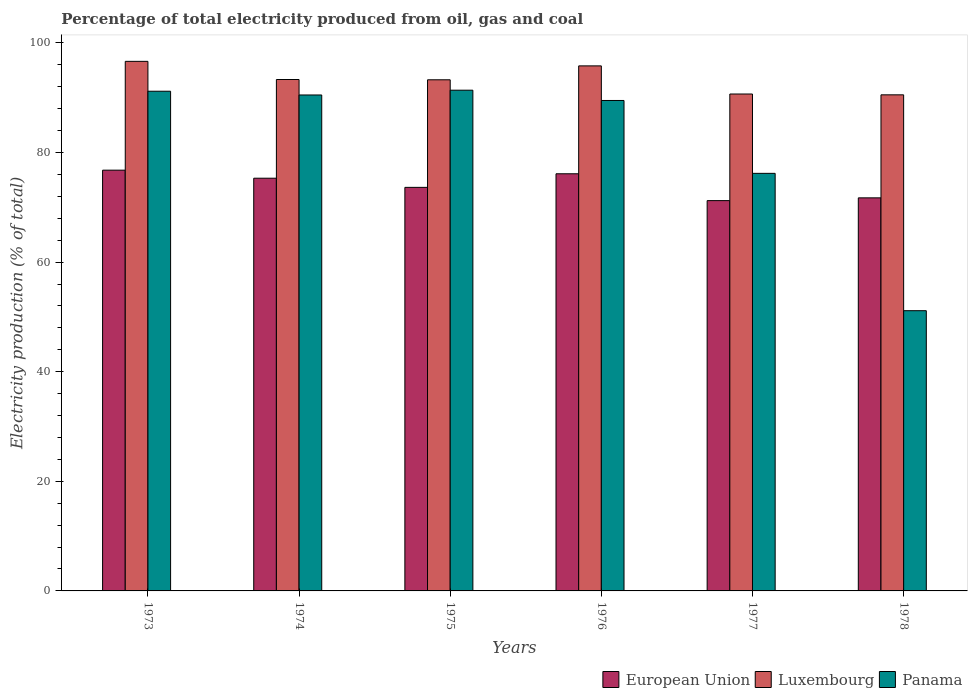How many different coloured bars are there?
Provide a succinct answer. 3. Are the number of bars per tick equal to the number of legend labels?
Offer a very short reply. Yes. Are the number of bars on each tick of the X-axis equal?
Your response must be concise. Yes. How many bars are there on the 3rd tick from the right?
Keep it short and to the point. 3. What is the label of the 3rd group of bars from the left?
Offer a very short reply. 1975. What is the electricity production in in Luxembourg in 1974?
Offer a very short reply. 93.32. Across all years, what is the maximum electricity production in in Panama?
Offer a terse response. 91.37. Across all years, what is the minimum electricity production in in European Union?
Offer a very short reply. 71.22. In which year was the electricity production in in Luxembourg minimum?
Keep it short and to the point. 1978. What is the total electricity production in in European Union in the graph?
Provide a short and direct response. 444.77. What is the difference between the electricity production in in Panama in 1973 and that in 1974?
Provide a succinct answer. 0.69. What is the difference between the electricity production in in Luxembourg in 1977 and the electricity production in in Panama in 1976?
Offer a very short reply. 1.18. What is the average electricity production in in European Union per year?
Provide a short and direct response. 74.13. In the year 1975, what is the difference between the electricity production in in European Union and electricity production in in Luxembourg?
Give a very brief answer. -19.63. In how many years, is the electricity production in in Luxembourg greater than 44 %?
Give a very brief answer. 6. What is the ratio of the electricity production in in Panama in 1974 to that in 1977?
Offer a very short reply. 1.19. Is the electricity production in in Luxembourg in 1973 less than that in 1974?
Your response must be concise. No. What is the difference between the highest and the second highest electricity production in in Luxembourg?
Make the answer very short. 0.83. What is the difference between the highest and the lowest electricity production in in Panama?
Your answer should be very brief. 40.24. In how many years, is the electricity production in in Panama greater than the average electricity production in in Panama taken over all years?
Your answer should be very brief. 4. What does the 1st bar from the left in 1973 represents?
Your answer should be very brief. European Union. What does the 1st bar from the right in 1973 represents?
Give a very brief answer. Panama. Is it the case that in every year, the sum of the electricity production in in Luxembourg and electricity production in in Panama is greater than the electricity production in in European Union?
Offer a very short reply. Yes. How many bars are there?
Offer a very short reply. 18. Are all the bars in the graph horizontal?
Make the answer very short. No. Where does the legend appear in the graph?
Provide a succinct answer. Bottom right. How many legend labels are there?
Provide a short and direct response. 3. What is the title of the graph?
Offer a terse response. Percentage of total electricity produced from oil, gas and coal. What is the label or title of the Y-axis?
Keep it short and to the point. Electricity production (% of total). What is the Electricity production (% of total) of European Union in 1973?
Make the answer very short. 76.77. What is the Electricity production (% of total) of Luxembourg in 1973?
Your answer should be very brief. 96.63. What is the Electricity production (% of total) of Panama in 1973?
Your answer should be compact. 91.18. What is the Electricity production (% of total) of European Union in 1974?
Provide a succinct answer. 75.3. What is the Electricity production (% of total) in Luxembourg in 1974?
Offer a very short reply. 93.32. What is the Electricity production (% of total) in Panama in 1974?
Your response must be concise. 90.49. What is the Electricity production (% of total) of European Union in 1975?
Your response must be concise. 73.63. What is the Electricity production (% of total) in Luxembourg in 1975?
Your answer should be very brief. 93.26. What is the Electricity production (% of total) in Panama in 1975?
Make the answer very short. 91.37. What is the Electricity production (% of total) in European Union in 1976?
Keep it short and to the point. 76.11. What is the Electricity production (% of total) of Luxembourg in 1976?
Provide a short and direct response. 95.8. What is the Electricity production (% of total) of Panama in 1976?
Provide a short and direct response. 89.49. What is the Electricity production (% of total) in European Union in 1977?
Keep it short and to the point. 71.22. What is the Electricity production (% of total) of Luxembourg in 1977?
Make the answer very short. 90.67. What is the Electricity production (% of total) of Panama in 1977?
Offer a terse response. 76.19. What is the Electricity production (% of total) in European Union in 1978?
Your answer should be very brief. 71.72. What is the Electricity production (% of total) in Luxembourg in 1978?
Make the answer very short. 90.52. What is the Electricity production (% of total) in Panama in 1978?
Offer a terse response. 51.13. Across all years, what is the maximum Electricity production (% of total) of European Union?
Your answer should be very brief. 76.77. Across all years, what is the maximum Electricity production (% of total) in Luxembourg?
Your answer should be very brief. 96.63. Across all years, what is the maximum Electricity production (% of total) in Panama?
Give a very brief answer. 91.37. Across all years, what is the minimum Electricity production (% of total) in European Union?
Make the answer very short. 71.22. Across all years, what is the minimum Electricity production (% of total) of Luxembourg?
Ensure brevity in your answer.  90.52. Across all years, what is the minimum Electricity production (% of total) in Panama?
Keep it short and to the point. 51.13. What is the total Electricity production (% of total) of European Union in the graph?
Your answer should be very brief. 444.77. What is the total Electricity production (% of total) in Luxembourg in the graph?
Offer a very short reply. 560.2. What is the total Electricity production (% of total) in Panama in the graph?
Your response must be concise. 489.85. What is the difference between the Electricity production (% of total) of European Union in 1973 and that in 1974?
Provide a short and direct response. 1.47. What is the difference between the Electricity production (% of total) of Luxembourg in 1973 and that in 1974?
Keep it short and to the point. 3.31. What is the difference between the Electricity production (% of total) of Panama in 1973 and that in 1974?
Provide a succinct answer. 0.69. What is the difference between the Electricity production (% of total) of European Union in 1973 and that in 1975?
Your answer should be compact. 3.14. What is the difference between the Electricity production (% of total) in Luxembourg in 1973 and that in 1975?
Keep it short and to the point. 3.36. What is the difference between the Electricity production (% of total) in Panama in 1973 and that in 1975?
Your response must be concise. -0.19. What is the difference between the Electricity production (% of total) of European Union in 1973 and that in 1976?
Provide a succinct answer. 0.66. What is the difference between the Electricity production (% of total) of Luxembourg in 1973 and that in 1976?
Offer a very short reply. 0.83. What is the difference between the Electricity production (% of total) of Panama in 1973 and that in 1976?
Your answer should be very brief. 1.69. What is the difference between the Electricity production (% of total) of European Union in 1973 and that in 1977?
Give a very brief answer. 5.56. What is the difference between the Electricity production (% of total) of Luxembourg in 1973 and that in 1977?
Your response must be concise. 5.96. What is the difference between the Electricity production (% of total) in Panama in 1973 and that in 1977?
Offer a terse response. 14.99. What is the difference between the Electricity production (% of total) in European Union in 1973 and that in 1978?
Your response must be concise. 5.05. What is the difference between the Electricity production (% of total) of Luxembourg in 1973 and that in 1978?
Your response must be concise. 6.11. What is the difference between the Electricity production (% of total) in Panama in 1973 and that in 1978?
Your answer should be very brief. 40.05. What is the difference between the Electricity production (% of total) of European Union in 1974 and that in 1975?
Your answer should be very brief. 1.67. What is the difference between the Electricity production (% of total) in Luxembourg in 1974 and that in 1975?
Offer a terse response. 0.05. What is the difference between the Electricity production (% of total) of Panama in 1974 and that in 1975?
Your answer should be very brief. -0.87. What is the difference between the Electricity production (% of total) in European Union in 1974 and that in 1976?
Provide a succinct answer. -0.81. What is the difference between the Electricity production (% of total) in Luxembourg in 1974 and that in 1976?
Provide a short and direct response. -2.49. What is the difference between the Electricity production (% of total) of Panama in 1974 and that in 1976?
Give a very brief answer. 1. What is the difference between the Electricity production (% of total) in European Union in 1974 and that in 1977?
Ensure brevity in your answer.  4.09. What is the difference between the Electricity production (% of total) of Luxembourg in 1974 and that in 1977?
Offer a very short reply. 2.65. What is the difference between the Electricity production (% of total) in Panama in 1974 and that in 1977?
Ensure brevity in your answer.  14.3. What is the difference between the Electricity production (% of total) of European Union in 1974 and that in 1978?
Give a very brief answer. 3.58. What is the difference between the Electricity production (% of total) in Luxembourg in 1974 and that in 1978?
Ensure brevity in your answer.  2.8. What is the difference between the Electricity production (% of total) of Panama in 1974 and that in 1978?
Your answer should be compact. 39.36. What is the difference between the Electricity production (% of total) in European Union in 1975 and that in 1976?
Offer a terse response. -2.48. What is the difference between the Electricity production (% of total) in Luxembourg in 1975 and that in 1976?
Make the answer very short. -2.54. What is the difference between the Electricity production (% of total) in Panama in 1975 and that in 1976?
Your answer should be very brief. 1.88. What is the difference between the Electricity production (% of total) in European Union in 1975 and that in 1977?
Offer a very short reply. 2.42. What is the difference between the Electricity production (% of total) in Luxembourg in 1975 and that in 1977?
Your response must be concise. 2.59. What is the difference between the Electricity production (% of total) of Panama in 1975 and that in 1977?
Offer a very short reply. 15.17. What is the difference between the Electricity production (% of total) in European Union in 1975 and that in 1978?
Make the answer very short. 1.91. What is the difference between the Electricity production (% of total) of Luxembourg in 1975 and that in 1978?
Your answer should be compact. 2.75. What is the difference between the Electricity production (% of total) in Panama in 1975 and that in 1978?
Provide a succinct answer. 40.24. What is the difference between the Electricity production (% of total) of European Union in 1976 and that in 1977?
Your answer should be compact. 4.9. What is the difference between the Electricity production (% of total) in Luxembourg in 1976 and that in 1977?
Your answer should be compact. 5.13. What is the difference between the Electricity production (% of total) in Panama in 1976 and that in 1977?
Your answer should be very brief. 13.29. What is the difference between the Electricity production (% of total) in European Union in 1976 and that in 1978?
Make the answer very short. 4.39. What is the difference between the Electricity production (% of total) of Luxembourg in 1976 and that in 1978?
Your response must be concise. 5.28. What is the difference between the Electricity production (% of total) of Panama in 1976 and that in 1978?
Provide a succinct answer. 38.36. What is the difference between the Electricity production (% of total) in European Union in 1977 and that in 1978?
Offer a terse response. -0.5. What is the difference between the Electricity production (% of total) of Luxembourg in 1977 and that in 1978?
Make the answer very short. 0.15. What is the difference between the Electricity production (% of total) in Panama in 1977 and that in 1978?
Your response must be concise. 25.06. What is the difference between the Electricity production (% of total) of European Union in 1973 and the Electricity production (% of total) of Luxembourg in 1974?
Keep it short and to the point. -16.54. What is the difference between the Electricity production (% of total) of European Union in 1973 and the Electricity production (% of total) of Panama in 1974?
Make the answer very short. -13.72. What is the difference between the Electricity production (% of total) of Luxembourg in 1973 and the Electricity production (% of total) of Panama in 1974?
Your answer should be compact. 6.14. What is the difference between the Electricity production (% of total) in European Union in 1973 and the Electricity production (% of total) in Luxembourg in 1975?
Make the answer very short. -16.49. What is the difference between the Electricity production (% of total) of European Union in 1973 and the Electricity production (% of total) of Panama in 1975?
Offer a very short reply. -14.59. What is the difference between the Electricity production (% of total) in Luxembourg in 1973 and the Electricity production (% of total) in Panama in 1975?
Your response must be concise. 5.26. What is the difference between the Electricity production (% of total) of European Union in 1973 and the Electricity production (% of total) of Luxembourg in 1976?
Provide a short and direct response. -19.03. What is the difference between the Electricity production (% of total) in European Union in 1973 and the Electricity production (% of total) in Panama in 1976?
Keep it short and to the point. -12.72. What is the difference between the Electricity production (% of total) of Luxembourg in 1973 and the Electricity production (% of total) of Panama in 1976?
Your answer should be very brief. 7.14. What is the difference between the Electricity production (% of total) of European Union in 1973 and the Electricity production (% of total) of Luxembourg in 1977?
Ensure brevity in your answer.  -13.9. What is the difference between the Electricity production (% of total) of European Union in 1973 and the Electricity production (% of total) of Panama in 1977?
Your answer should be very brief. 0.58. What is the difference between the Electricity production (% of total) in Luxembourg in 1973 and the Electricity production (% of total) in Panama in 1977?
Your response must be concise. 20.43. What is the difference between the Electricity production (% of total) of European Union in 1973 and the Electricity production (% of total) of Luxembourg in 1978?
Your response must be concise. -13.74. What is the difference between the Electricity production (% of total) in European Union in 1973 and the Electricity production (% of total) in Panama in 1978?
Make the answer very short. 25.64. What is the difference between the Electricity production (% of total) in Luxembourg in 1973 and the Electricity production (% of total) in Panama in 1978?
Provide a succinct answer. 45.5. What is the difference between the Electricity production (% of total) of European Union in 1974 and the Electricity production (% of total) of Luxembourg in 1975?
Give a very brief answer. -17.96. What is the difference between the Electricity production (% of total) of European Union in 1974 and the Electricity production (% of total) of Panama in 1975?
Your response must be concise. -16.06. What is the difference between the Electricity production (% of total) in Luxembourg in 1974 and the Electricity production (% of total) in Panama in 1975?
Offer a very short reply. 1.95. What is the difference between the Electricity production (% of total) in European Union in 1974 and the Electricity production (% of total) in Luxembourg in 1976?
Offer a terse response. -20.5. What is the difference between the Electricity production (% of total) of European Union in 1974 and the Electricity production (% of total) of Panama in 1976?
Provide a short and direct response. -14.18. What is the difference between the Electricity production (% of total) in Luxembourg in 1974 and the Electricity production (% of total) in Panama in 1976?
Your answer should be very brief. 3.83. What is the difference between the Electricity production (% of total) in European Union in 1974 and the Electricity production (% of total) in Luxembourg in 1977?
Keep it short and to the point. -15.36. What is the difference between the Electricity production (% of total) in European Union in 1974 and the Electricity production (% of total) in Panama in 1977?
Your response must be concise. -0.89. What is the difference between the Electricity production (% of total) in Luxembourg in 1974 and the Electricity production (% of total) in Panama in 1977?
Give a very brief answer. 17.12. What is the difference between the Electricity production (% of total) of European Union in 1974 and the Electricity production (% of total) of Luxembourg in 1978?
Give a very brief answer. -15.21. What is the difference between the Electricity production (% of total) in European Union in 1974 and the Electricity production (% of total) in Panama in 1978?
Keep it short and to the point. 24.17. What is the difference between the Electricity production (% of total) in Luxembourg in 1974 and the Electricity production (% of total) in Panama in 1978?
Provide a succinct answer. 42.19. What is the difference between the Electricity production (% of total) in European Union in 1975 and the Electricity production (% of total) in Luxembourg in 1976?
Your answer should be very brief. -22.17. What is the difference between the Electricity production (% of total) in European Union in 1975 and the Electricity production (% of total) in Panama in 1976?
Provide a succinct answer. -15.85. What is the difference between the Electricity production (% of total) of Luxembourg in 1975 and the Electricity production (% of total) of Panama in 1976?
Keep it short and to the point. 3.78. What is the difference between the Electricity production (% of total) in European Union in 1975 and the Electricity production (% of total) in Luxembourg in 1977?
Offer a very short reply. -17.03. What is the difference between the Electricity production (% of total) in European Union in 1975 and the Electricity production (% of total) in Panama in 1977?
Offer a very short reply. -2.56. What is the difference between the Electricity production (% of total) of Luxembourg in 1975 and the Electricity production (% of total) of Panama in 1977?
Keep it short and to the point. 17.07. What is the difference between the Electricity production (% of total) of European Union in 1975 and the Electricity production (% of total) of Luxembourg in 1978?
Provide a short and direct response. -16.88. What is the difference between the Electricity production (% of total) of European Union in 1975 and the Electricity production (% of total) of Panama in 1978?
Keep it short and to the point. 22.5. What is the difference between the Electricity production (% of total) of Luxembourg in 1975 and the Electricity production (% of total) of Panama in 1978?
Provide a succinct answer. 42.13. What is the difference between the Electricity production (% of total) in European Union in 1976 and the Electricity production (% of total) in Luxembourg in 1977?
Offer a very short reply. -14.55. What is the difference between the Electricity production (% of total) of European Union in 1976 and the Electricity production (% of total) of Panama in 1977?
Your answer should be compact. -0.08. What is the difference between the Electricity production (% of total) in Luxembourg in 1976 and the Electricity production (% of total) in Panama in 1977?
Provide a succinct answer. 19.61. What is the difference between the Electricity production (% of total) of European Union in 1976 and the Electricity production (% of total) of Luxembourg in 1978?
Provide a succinct answer. -14.4. What is the difference between the Electricity production (% of total) in European Union in 1976 and the Electricity production (% of total) in Panama in 1978?
Offer a very short reply. 24.98. What is the difference between the Electricity production (% of total) in Luxembourg in 1976 and the Electricity production (% of total) in Panama in 1978?
Your answer should be very brief. 44.67. What is the difference between the Electricity production (% of total) of European Union in 1977 and the Electricity production (% of total) of Luxembourg in 1978?
Offer a very short reply. -19.3. What is the difference between the Electricity production (% of total) in European Union in 1977 and the Electricity production (% of total) in Panama in 1978?
Provide a succinct answer. 20.09. What is the difference between the Electricity production (% of total) in Luxembourg in 1977 and the Electricity production (% of total) in Panama in 1978?
Give a very brief answer. 39.54. What is the average Electricity production (% of total) of European Union per year?
Your answer should be very brief. 74.13. What is the average Electricity production (% of total) in Luxembourg per year?
Make the answer very short. 93.37. What is the average Electricity production (% of total) of Panama per year?
Offer a terse response. 81.64. In the year 1973, what is the difference between the Electricity production (% of total) in European Union and Electricity production (% of total) in Luxembourg?
Your response must be concise. -19.85. In the year 1973, what is the difference between the Electricity production (% of total) in European Union and Electricity production (% of total) in Panama?
Your answer should be compact. -14.41. In the year 1973, what is the difference between the Electricity production (% of total) in Luxembourg and Electricity production (% of total) in Panama?
Ensure brevity in your answer.  5.45. In the year 1974, what is the difference between the Electricity production (% of total) of European Union and Electricity production (% of total) of Luxembourg?
Make the answer very short. -18.01. In the year 1974, what is the difference between the Electricity production (% of total) in European Union and Electricity production (% of total) in Panama?
Offer a terse response. -15.19. In the year 1974, what is the difference between the Electricity production (% of total) in Luxembourg and Electricity production (% of total) in Panama?
Ensure brevity in your answer.  2.83. In the year 1975, what is the difference between the Electricity production (% of total) in European Union and Electricity production (% of total) in Luxembourg?
Ensure brevity in your answer.  -19.63. In the year 1975, what is the difference between the Electricity production (% of total) of European Union and Electricity production (% of total) of Panama?
Your answer should be very brief. -17.73. In the year 1975, what is the difference between the Electricity production (% of total) of Luxembourg and Electricity production (% of total) of Panama?
Give a very brief answer. 1.9. In the year 1976, what is the difference between the Electricity production (% of total) of European Union and Electricity production (% of total) of Luxembourg?
Provide a succinct answer. -19.69. In the year 1976, what is the difference between the Electricity production (% of total) of European Union and Electricity production (% of total) of Panama?
Provide a short and direct response. -13.37. In the year 1976, what is the difference between the Electricity production (% of total) of Luxembourg and Electricity production (% of total) of Panama?
Ensure brevity in your answer.  6.31. In the year 1977, what is the difference between the Electricity production (% of total) in European Union and Electricity production (% of total) in Luxembourg?
Your response must be concise. -19.45. In the year 1977, what is the difference between the Electricity production (% of total) of European Union and Electricity production (% of total) of Panama?
Provide a succinct answer. -4.98. In the year 1977, what is the difference between the Electricity production (% of total) of Luxembourg and Electricity production (% of total) of Panama?
Make the answer very short. 14.48. In the year 1978, what is the difference between the Electricity production (% of total) of European Union and Electricity production (% of total) of Luxembourg?
Your answer should be compact. -18.8. In the year 1978, what is the difference between the Electricity production (% of total) in European Union and Electricity production (% of total) in Panama?
Provide a succinct answer. 20.59. In the year 1978, what is the difference between the Electricity production (% of total) in Luxembourg and Electricity production (% of total) in Panama?
Your answer should be very brief. 39.39. What is the ratio of the Electricity production (% of total) of European Union in 1973 to that in 1974?
Offer a terse response. 1.02. What is the ratio of the Electricity production (% of total) of Luxembourg in 1973 to that in 1974?
Your response must be concise. 1.04. What is the ratio of the Electricity production (% of total) of Panama in 1973 to that in 1974?
Provide a short and direct response. 1.01. What is the ratio of the Electricity production (% of total) in European Union in 1973 to that in 1975?
Give a very brief answer. 1.04. What is the ratio of the Electricity production (% of total) of Luxembourg in 1973 to that in 1975?
Provide a short and direct response. 1.04. What is the ratio of the Electricity production (% of total) in European Union in 1973 to that in 1976?
Offer a terse response. 1.01. What is the ratio of the Electricity production (% of total) in Luxembourg in 1973 to that in 1976?
Give a very brief answer. 1.01. What is the ratio of the Electricity production (% of total) in Panama in 1973 to that in 1976?
Provide a succinct answer. 1.02. What is the ratio of the Electricity production (% of total) in European Union in 1973 to that in 1977?
Make the answer very short. 1.08. What is the ratio of the Electricity production (% of total) in Luxembourg in 1973 to that in 1977?
Your answer should be compact. 1.07. What is the ratio of the Electricity production (% of total) in Panama in 1973 to that in 1977?
Your answer should be very brief. 1.2. What is the ratio of the Electricity production (% of total) of European Union in 1973 to that in 1978?
Offer a very short reply. 1.07. What is the ratio of the Electricity production (% of total) of Luxembourg in 1973 to that in 1978?
Provide a succinct answer. 1.07. What is the ratio of the Electricity production (% of total) in Panama in 1973 to that in 1978?
Offer a very short reply. 1.78. What is the ratio of the Electricity production (% of total) in European Union in 1974 to that in 1975?
Keep it short and to the point. 1.02. What is the ratio of the Electricity production (% of total) in Panama in 1974 to that in 1975?
Offer a very short reply. 0.99. What is the ratio of the Electricity production (% of total) of European Union in 1974 to that in 1976?
Ensure brevity in your answer.  0.99. What is the ratio of the Electricity production (% of total) of Luxembourg in 1974 to that in 1976?
Keep it short and to the point. 0.97. What is the ratio of the Electricity production (% of total) in Panama in 1974 to that in 1976?
Offer a terse response. 1.01. What is the ratio of the Electricity production (% of total) in European Union in 1974 to that in 1977?
Offer a very short reply. 1.06. What is the ratio of the Electricity production (% of total) of Luxembourg in 1974 to that in 1977?
Ensure brevity in your answer.  1.03. What is the ratio of the Electricity production (% of total) in Panama in 1974 to that in 1977?
Offer a very short reply. 1.19. What is the ratio of the Electricity production (% of total) of Luxembourg in 1974 to that in 1978?
Your response must be concise. 1.03. What is the ratio of the Electricity production (% of total) of Panama in 1974 to that in 1978?
Keep it short and to the point. 1.77. What is the ratio of the Electricity production (% of total) in European Union in 1975 to that in 1976?
Your answer should be compact. 0.97. What is the ratio of the Electricity production (% of total) of Luxembourg in 1975 to that in 1976?
Offer a terse response. 0.97. What is the ratio of the Electricity production (% of total) of Panama in 1975 to that in 1976?
Keep it short and to the point. 1.02. What is the ratio of the Electricity production (% of total) in European Union in 1975 to that in 1977?
Your answer should be very brief. 1.03. What is the ratio of the Electricity production (% of total) in Luxembourg in 1975 to that in 1977?
Offer a terse response. 1.03. What is the ratio of the Electricity production (% of total) in Panama in 1975 to that in 1977?
Offer a terse response. 1.2. What is the ratio of the Electricity production (% of total) in European Union in 1975 to that in 1978?
Keep it short and to the point. 1.03. What is the ratio of the Electricity production (% of total) of Luxembourg in 1975 to that in 1978?
Provide a short and direct response. 1.03. What is the ratio of the Electricity production (% of total) of Panama in 1975 to that in 1978?
Keep it short and to the point. 1.79. What is the ratio of the Electricity production (% of total) of European Union in 1976 to that in 1977?
Your response must be concise. 1.07. What is the ratio of the Electricity production (% of total) of Luxembourg in 1976 to that in 1977?
Provide a succinct answer. 1.06. What is the ratio of the Electricity production (% of total) of Panama in 1976 to that in 1977?
Offer a terse response. 1.17. What is the ratio of the Electricity production (% of total) of European Union in 1976 to that in 1978?
Your answer should be very brief. 1.06. What is the ratio of the Electricity production (% of total) in Luxembourg in 1976 to that in 1978?
Ensure brevity in your answer.  1.06. What is the ratio of the Electricity production (% of total) of Panama in 1976 to that in 1978?
Offer a very short reply. 1.75. What is the ratio of the Electricity production (% of total) of European Union in 1977 to that in 1978?
Make the answer very short. 0.99. What is the ratio of the Electricity production (% of total) of Luxembourg in 1977 to that in 1978?
Offer a very short reply. 1. What is the ratio of the Electricity production (% of total) of Panama in 1977 to that in 1978?
Provide a short and direct response. 1.49. What is the difference between the highest and the second highest Electricity production (% of total) in European Union?
Ensure brevity in your answer.  0.66. What is the difference between the highest and the second highest Electricity production (% of total) of Luxembourg?
Ensure brevity in your answer.  0.83. What is the difference between the highest and the second highest Electricity production (% of total) in Panama?
Provide a short and direct response. 0.19. What is the difference between the highest and the lowest Electricity production (% of total) of European Union?
Provide a short and direct response. 5.56. What is the difference between the highest and the lowest Electricity production (% of total) of Luxembourg?
Provide a succinct answer. 6.11. What is the difference between the highest and the lowest Electricity production (% of total) in Panama?
Offer a very short reply. 40.24. 